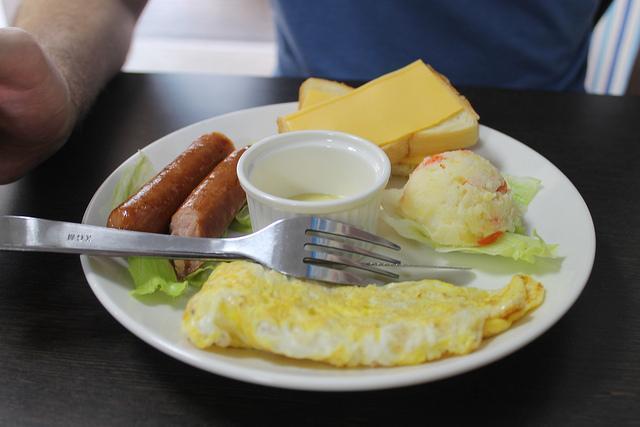Does the image validate the caption "The person is touching the sandwich."?
Answer yes or no. No. 